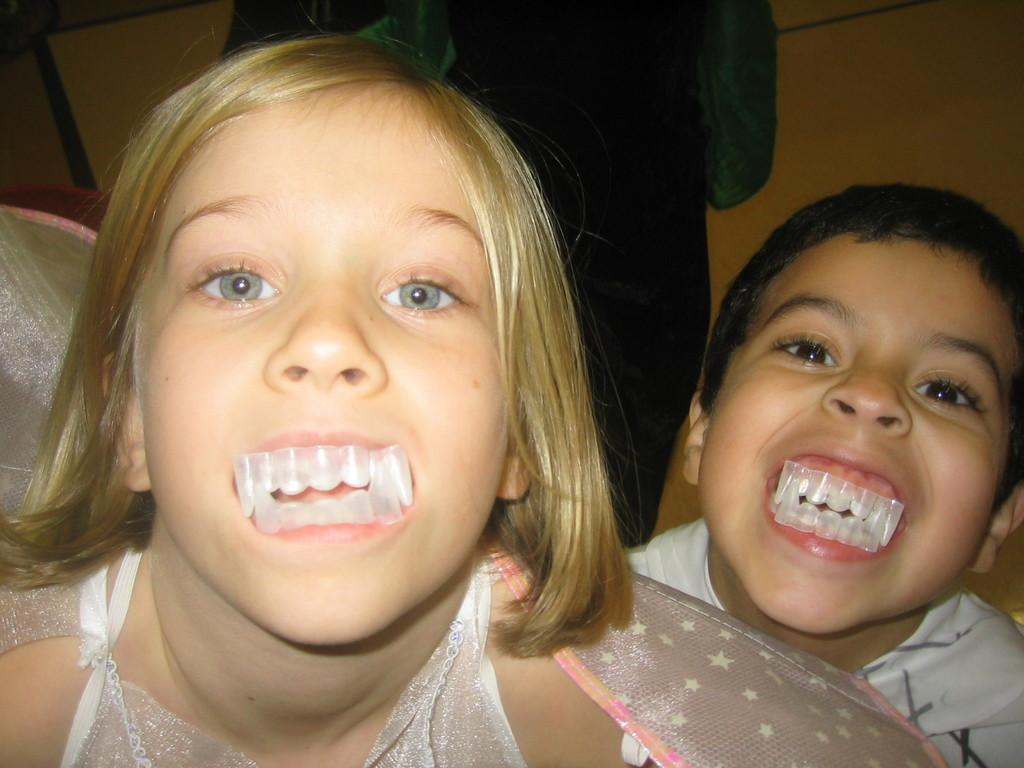How many people are present in the image? There are two people, a boy and a girl, present in the image. What are the boy and girl wearing in the image? Both the boy and girl are wearing tooth clips in the image. What can be seen behind the boy and girl? There is a wall visible in the image. Is there anyone else in the image besides the boy and girl? Yes, there is a person standing on the backside of the image. What type of stone can be seen being used for writing in the image? There is no stone or writing present in the image. What kind of noise can be heard coming from the person standing on the backside of the image? The image is silent, so no noise can be heard. 